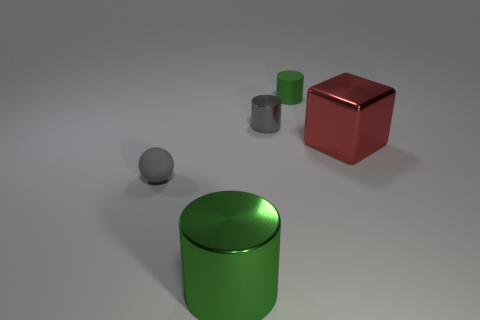There is a tiny thing that is the same color as the big metal cylinder; what material is it?
Make the answer very short. Rubber. Is there any other thing that has the same shape as the large green thing?
Your answer should be compact. Yes. Are there any small gray things?
Give a very brief answer. Yes. Is the material of the tiny gray thing that is in front of the red block the same as the large thing right of the green metallic object?
Offer a very short reply. No. What size is the metal thing to the right of the shiny thing behind the large thing on the right side of the tiny green cylinder?
Offer a very short reply. Large. How many green cylinders have the same material as the gray sphere?
Keep it short and to the point. 1. Are there fewer large red things than green cylinders?
Your response must be concise. Yes. There is a green metal thing that is the same shape as the gray metal thing; what is its size?
Give a very brief answer. Large. Are the green thing left of the tiny metal thing and the red object made of the same material?
Your answer should be very brief. Yes. Is the large red metallic object the same shape as the small shiny thing?
Provide a short and direct response. No. 